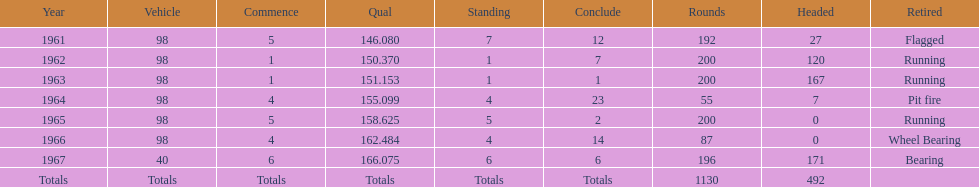What car ranked #1 from 1962-1963? 98. 